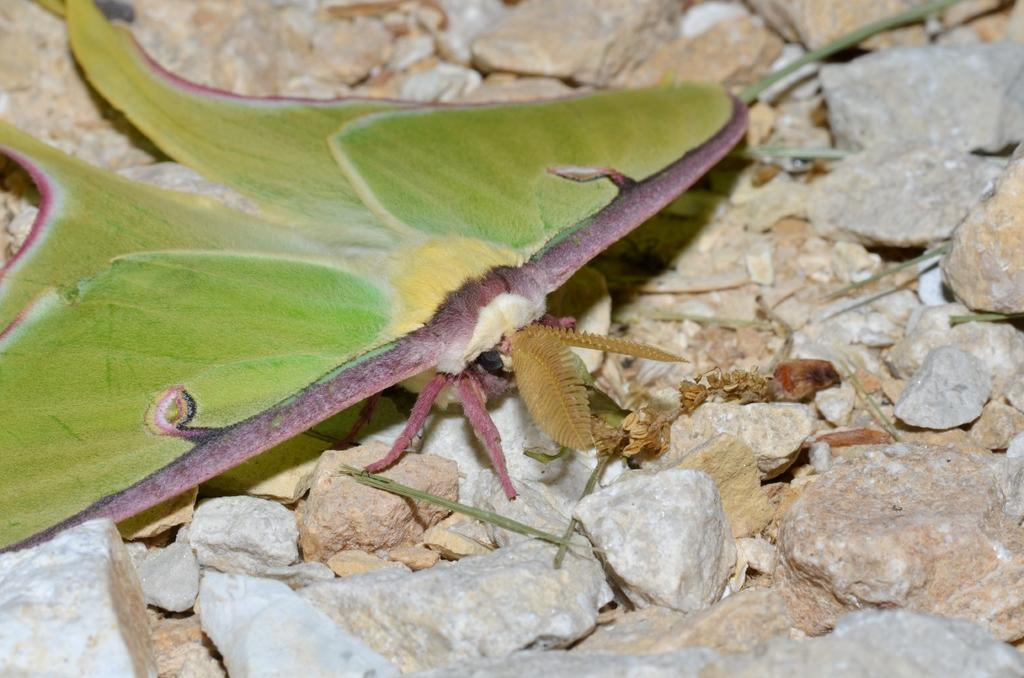What is the main subject of the image? There is an insect in the image. Where is the insect located? The insect is on stones. Can you describe the position of the insect in the image? The insect is in the center of the image. What type of theory is the insect discussing with the cars in the image? There are no cars present in the image, and insects do not discuss theories. 